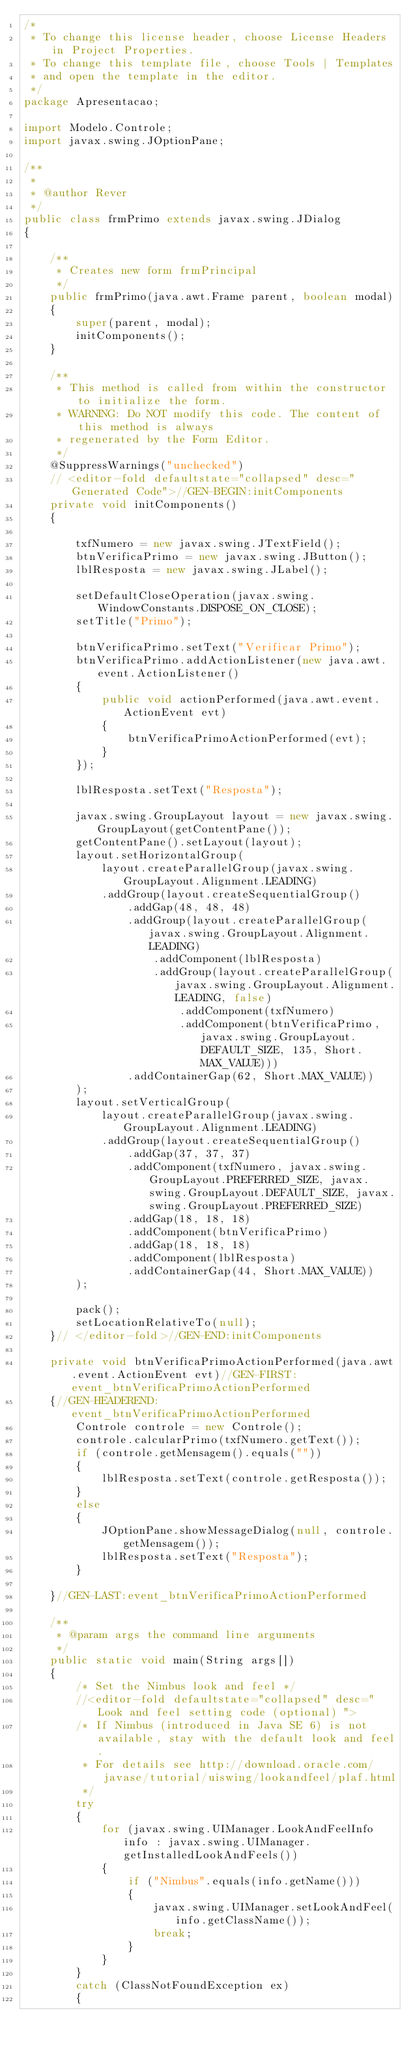Convert code to text. <code><loc_0><loc_0><loc_500><loc_500><_Java_>/*
 * To change this license header, choose License Headers in Project Properties.
 * To change this template file, choose Tools | Templates
 * and open the template in the editor.
 */
package Apresentacao;

import Modelo.Controle;
import javax.swing.JOptionPane;

/**
 *
 * @author Rever
 */
public class frmPrimo extends javax.swing.JDialog
{

    /**
     * Creates new form frmPrincipal
     */
    public frmPrimo(java.awt.Frame parent, boolean modal)
    {
        super(parent, modal);
        initComponents();
    }

    /**
     * This method is called from within the constructor to initialize the form.
     * WARNING: Do NOT modify this code. The content of this method is always
     * regenerated by the Form Editor.
     */
    @SuppressWarnings("unchecked")
    // <editor-fold defaultstate="collapsed" desc="Generated Code">//GEN-BEGIN:initComponents
    private void initComponents()
    {

        txfNumero = new javax.swing.JTextField();
        btnVerificaPrimo = new javax.swing.JButton();
        lblResposta = new javax.swing.JLabel();

        setDefaultCloseOperation(javax.swing.WindowConstants.DISPOSE_ON_CLOSE);
        setTitle("Primo");

        btnVerificaPrimo.setText("Verificar Primo");
        btnVerificaPrimo.addActionListener(new java.awt.event.ActionListener()
        {
            public void actionPerformed(java.awt.event.ActionEvent evt)
            {
                btnVerificaPrimoActionPerformed(evt);
            }
        });

        lblResposta.setText("Resposta");

        javax.swing.GroupLayout layout = new javax.swing.GroupLayout(getContentPane());
        getContentPane().setLayout(layout);
        layout.setHorizontalGroup(
            layout.createParallelGroup(javax.swing.GroupLayout.Alignment.LEADING)
            .addGroup(layout.createSequentialGroup()
                .addGap(48, 48, 48)
                .addGroup(layout.createParallelGroup(javax.swing.GroupLayout.Alignment.LEADING)
                    .addComponent(lblResposta)
                    .addGroup(layout.createParallelGroup(javax.swing.GroupLayout.Alignment.LEADING, false)
                        .addComponent(txfNumero)
                        .addComponent(btnVerificaPrimo, javax.swing.GroupLayout.DEFAULT_SIZE, 135, Short.MAX_VALUE)))
                .addContainerGap(62, Short.MAX_VALUE))
        );
        layout.setVerticalGroup(
            layout.createParallelGroup(javax.swing.GroupLayout.Alignment.LEADING)
            .addGroup(layout.createSequentialGroup()
                .addGap(37, 37, 37)
                .addComponent(txfNumero, javax.swing.GroupLayout.PREFERRED_SIZE, javax.swing.GroupLayout.DEFAULT_SIZE, javax.swing.GroupLayout.PREFERRED_SIZE)
                .addGap(18, 18, 18)
                .addComponent(btnVerificaPrimo)
                .addGap(18, 18, 18)
                .addComponent(lblResposta)
                .addContainerGap(44, Short.MAX_VALUE))
        );

        pack();
        setLocationRelativeTo(null);
    }// </editor-fold>//GEN-END:initComponents

    private void btnVerificaPrimoActionPerformed(java.awt.event.ActionEvent evt)//GEN-FIRST:event_btnVerificaPrimoActionPerformed
    {//GEN-HEADEREND:event_btnVerificaPrimoActionPerformed
        Controle controle = new Controle();
        controle.calcularPrimo(txfNumero.getText());
        if (controle.getMensagem().equals(""))
        {
            lblResposta.setText(controle.getResposta());
        }
        else
        {
            JOptionPane.showMessageDialog(null, controle.getMensagem());
            lblResposta.setText("Resposta");
        }
        
    }//GEN-LAST:event_btnVerificaPrimoActionPerformed

    /**
     * @param args the command line arguments
     */
    public static void main(String args[])
    {
        /* Set the Nimbus look and feel */
        //<editor-fold defaultstate="collapsed" desc=" Look and feel setting code (optional) ">
        /* If Nimbus (introduced in Java SE 6) is not available, stay with the default look and feel.
         * For details see http://download.oracle.com/javase/tutorial/uiswing/lookandfeel/plaf.html 
         */
        try
        {
            for (javax.swing.UIManager.LookAndFeelInfo info : javax.swing.UIManager.getInstalledLookAndFeels())
            {
                if ("Nimbus".equals(info.getName()))
                {
                    javax.swing.UIManager.setLookAndFeel(info.getClassName());
                    break;
                }
            }
        }
        catch (ClassNotFoundException ex)
        {</code> 